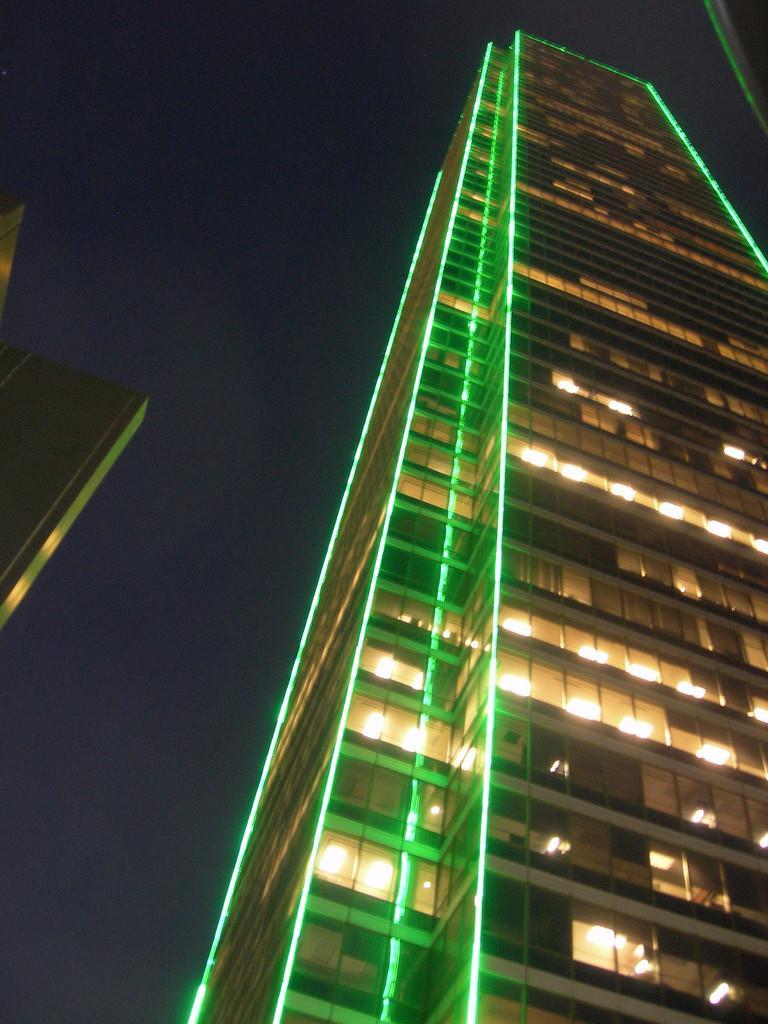Describe this image in one or two sentences. In this image there is a building truncated towards the right of the image, there is a building truncated towards the left of the image, there are lights on the building, the background of the image is dark. 